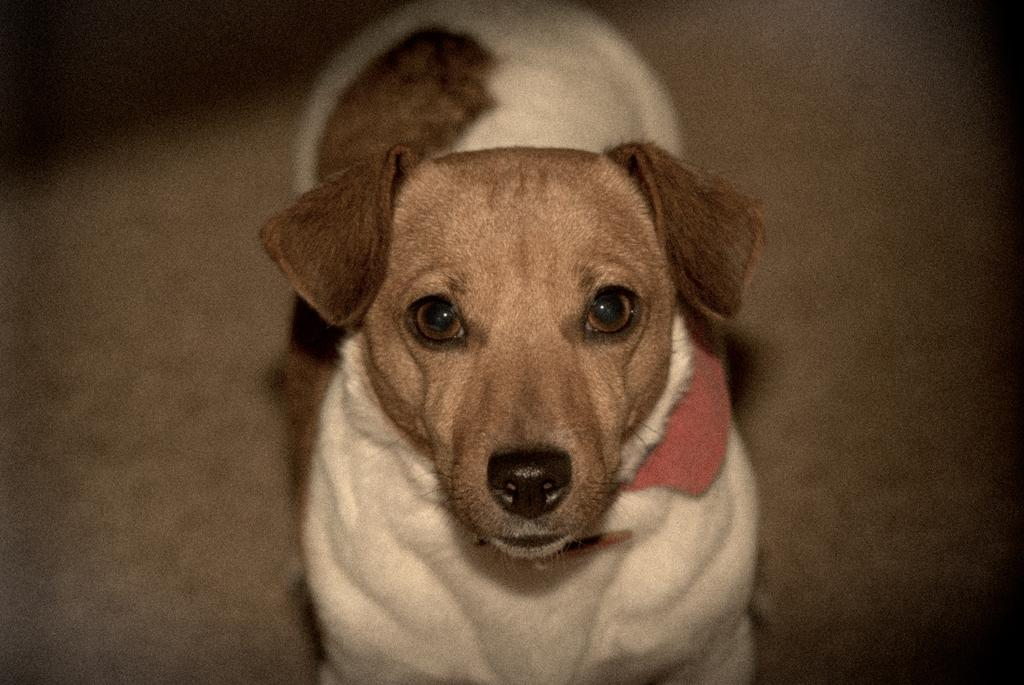What type of animal is in the image? There is a white and brown dog in the image. What is the dog doing in the image? The dog is standing. Can you describe the background of the image? The background of the image is blurred. What type of muscle is visible on the dog's back in the image? There is no specific muscle visible on the dog's back in the image; it is not possible to identify individual muscles from the provided facts. 